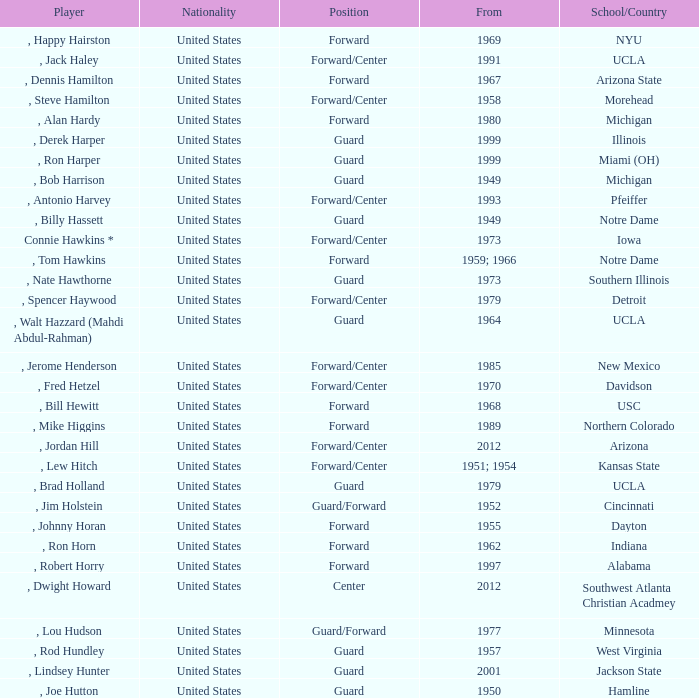From which school does the player who commenced playing in 1958 come from? Morehead. 